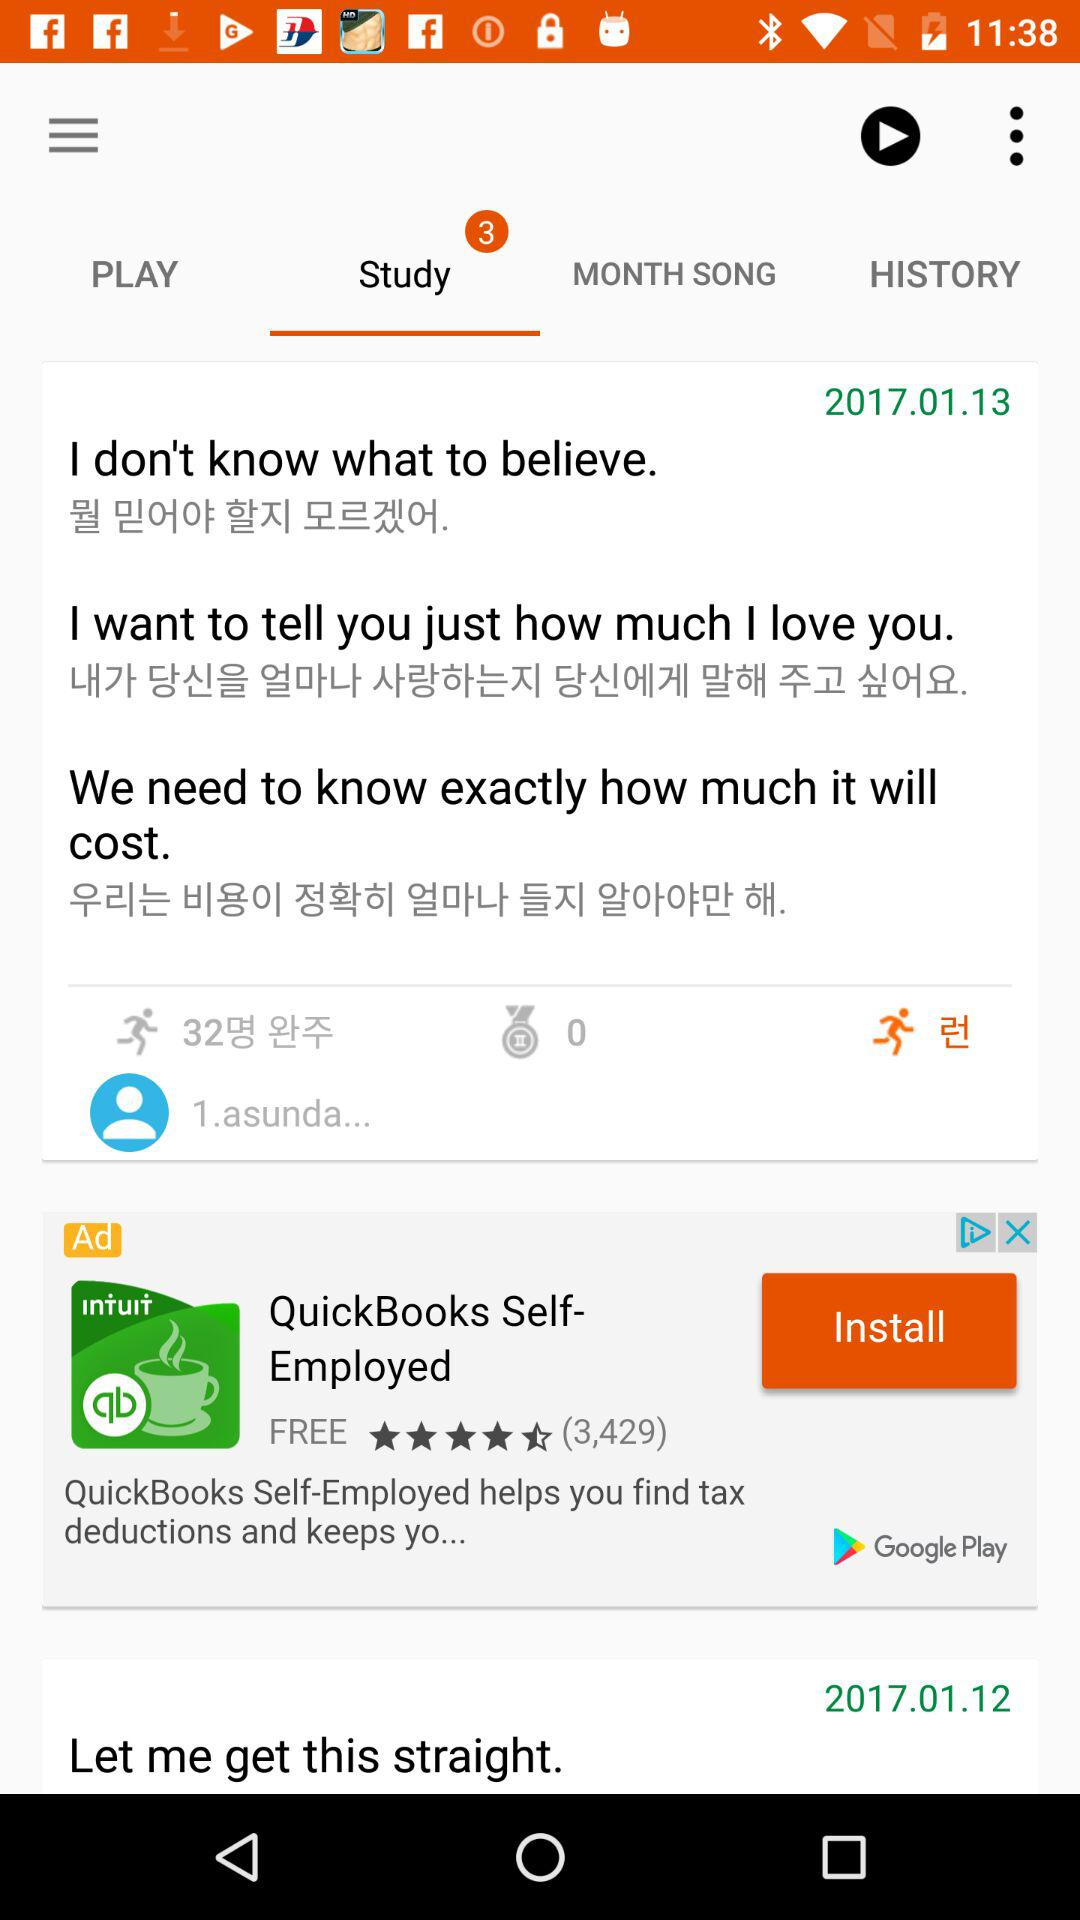Which tab is selected? The selected tab is "Study". 